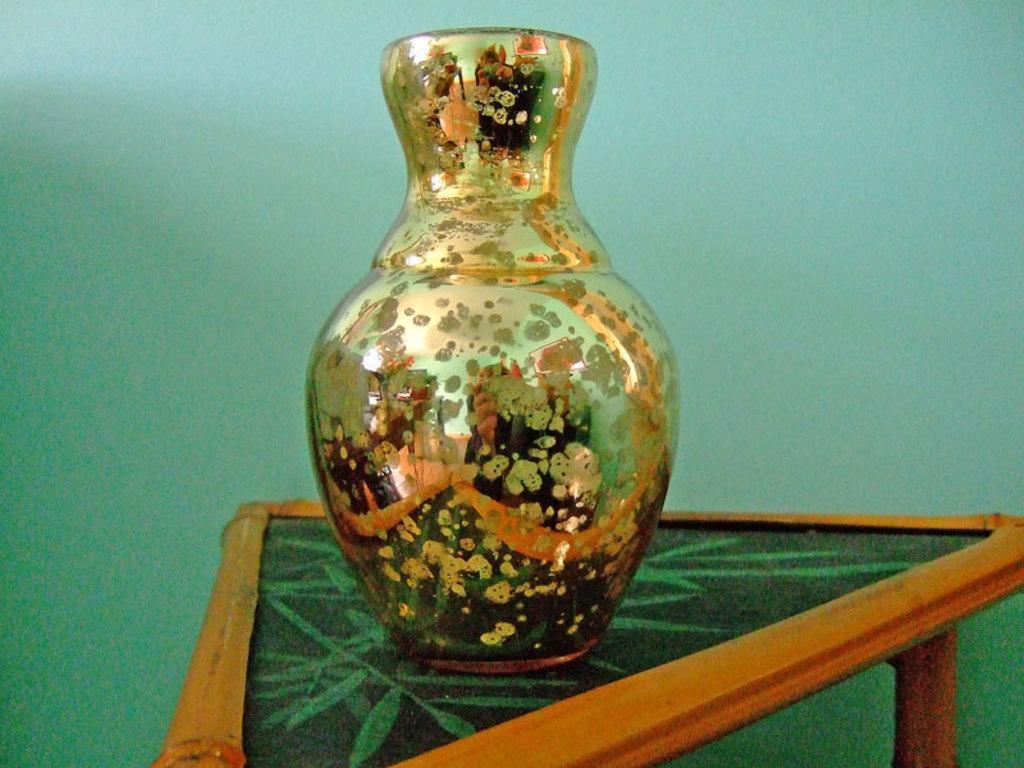In one or two sentences, can you explain what this image depicts? In this picture we can see a vase on a table and in the background we can see the wall. 